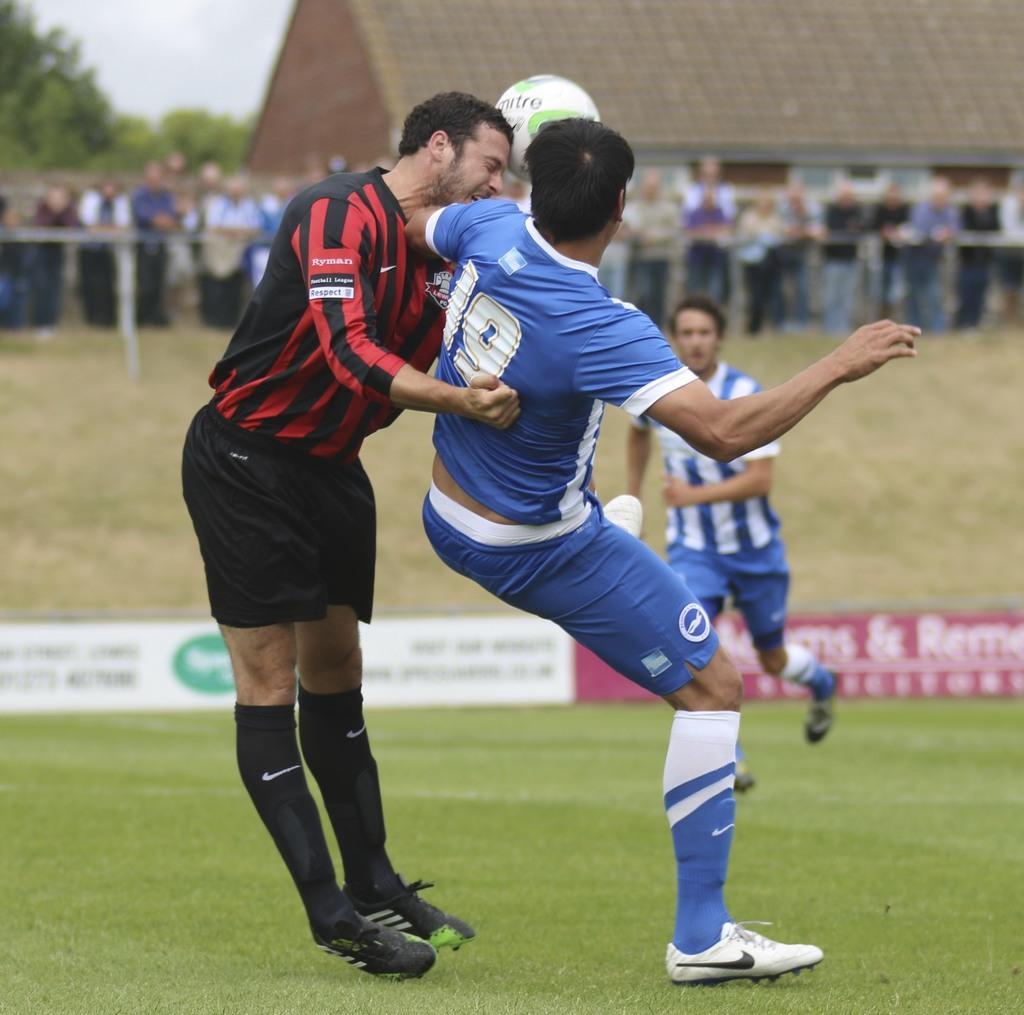How would you summarize this image in a sentence or two? In this picture we can see three persons playing a football game, at the bottom there is grass, in the background there are some people standing and looking at the game, we can see trees and the sky at the left top of the picture, there is a hoarding here. 